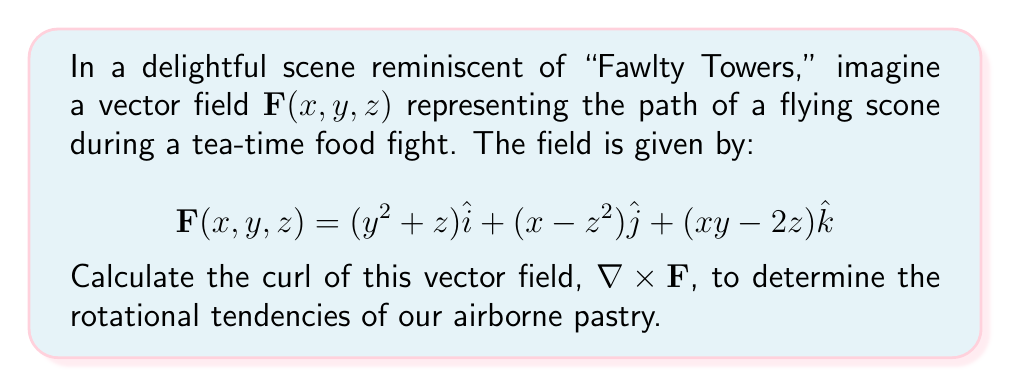Can you answer this question? Let's approach this step-by-step, just as methodically as Mrs. Bucket would plan her candlelight suppers:

1) The curl of a vector field in 3D is defined as:

   $$\nabla \times \mathbf{F} = \left(\frac{\partial F_z}{\partial y} - \frac{\partial F_y}{\partial z}\right)\hat{i} + \left(\frac{\partial F_x}{\partial z} - \frac{\partial F_z}{\partial x}\right)\hat{j} + \left(\frac{\partial F_y}{\partial x} - \frac{\partial F_x}{\partial y}\right)\hat{k}$$

2) Let's identify each component of $\mathbf{F}$:
   $F_x = y^2 + z$
   $F_y = x - z^2$
   $F_z = xy - 2z$

3) Now, let's calculate each partial derivative:

   $\frac{\partial F_z}{\partial y} = x$
   $\frac{\partial F_y}{\partial z} = -2z$
   $\frac{\partial F_x}{\partial z} = 1$
   $\frac{\partial F_z}{\partial x} = y$
   $\frac{\partial F_y}{\partial x} = 1$
   $\frac{\partial F_x}{\partial y} = 2y$

4) Now we can substitute these into our curl formula:

   $\nabla \times \mathbf{F} = (x + 2z)\hat{i} + (1 - y)\hat{j} + (1 - 2y)\hat{k}$

5) Simplify:

   $\nabla \times \mathbf{F} = (x + 2z)\hat{i} + (1 - y)\hat{j} + (1 - 2y)\hat{k}$

This result gives us the rotational tendencies of our flying scone at any point (x, y, z) in the room, much like how Manuel might spin while dodging Basil's temper!
Answer: $$(x + 2z)\hat{i} + (1 - y)\hat{j} + (1 - 2y)\hat{k}$$ 